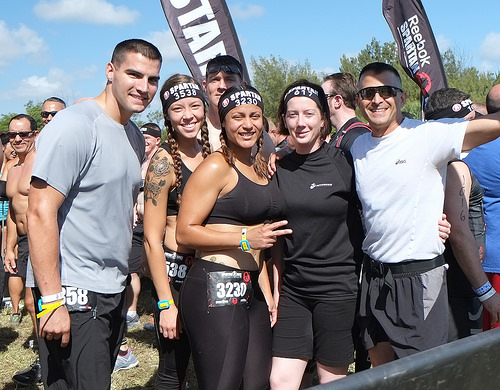<image>
Is the flag behind the tree? No. The flag is not behind the tree. From this viewpoint, the flag appears to be positioned elsewhere in the scene. 